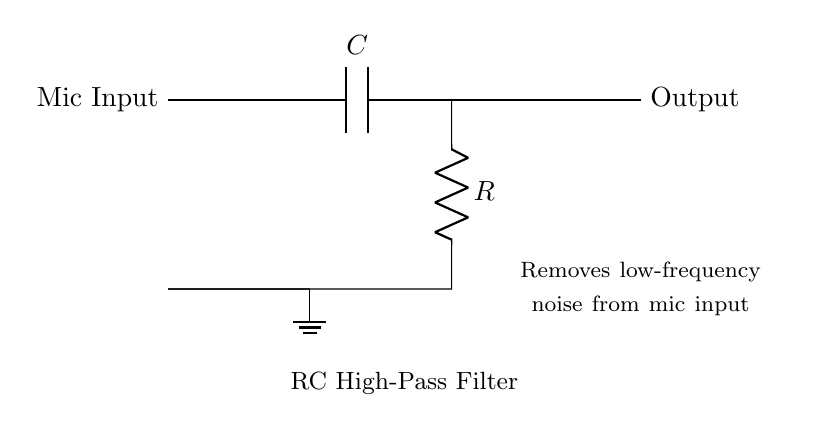What is the function of the capacitor in this circuit? The capacitor blocks low-frequency signals while allowing high-frequency signals to pass through, which makes it essential for filtering out unwanted low-frequency noise from the microphone input.
Answer: high-pass filter What is the value of the resistor? The diagram does not specify a numerical value for the resistor, so the value is assumed to be a variable representation.
Answer: R What type of filter is this circuit implementing? The circuit is designed as a high-pass filter, which is explicitly indicated in the labeling of the RC high-pass filter in the diagram.
Answer: high-pass filter What happens to low-frequency signals in this circuit? Low-frequency signals are attenuated or blocked by the capacitor, preventing them from reaching the output. This allows only high-frequency signals to pass through.
Answer: attenuated What is connected to the ground in the circuit? The ground connection is directly linked to the output side of the resistor, providing a return path for the electrical current.
Answer: resistor How is the output connected in this circuit? The output is taken from the junction between the capacitor and the resistor, allowing the filtered high-frequency signals to exit the circuit.
Answer: capacitor and resistor connection 